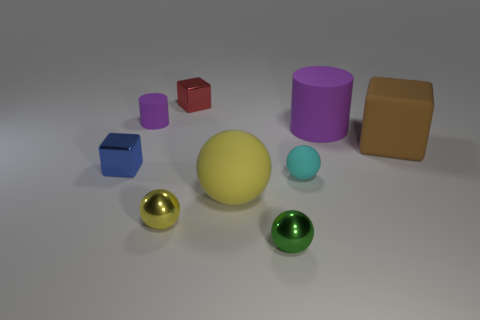What number of other things are the same shape as the tiny red thing?
Offer a very short reply. 2. Does the small matte thing behind the small blue metal thing have the same color as the matte ball that is to the left of the small rubber ball?
Give a very brief answer. No. There is a cylinder that is the same size as the cyan matte ball; what is its color?
Your response must be concise. Purple. Are there any large rubber cylinders that have the same color as the big sphere?
Provide a succinct answer. No. Is the size of the yellow ball to the left of the red block the same as the brown block?
Provide a short and direct response. No. Is the number of small metallic balls left of the green metallic ball the same as the number of tiny rubber cylinders?
Offer a terse response. Yes. How many objects are either cubes on the left side of the red thing or tiny yellow rubber things?
Provide a succinct answer. 1. There is a big matte thing that is to the left of the brown matte object and on the right side of the green metal object; what is its shape?
Your response must be concise. Cylinder. How many objects are rubber objects behind the small blue metal cube or purple matte cylinders to the left of the cyan sphere?
Make the answer very short. 3. How many other things are the same size as the blue cube?
Ensure brevity in your answer.  5. 